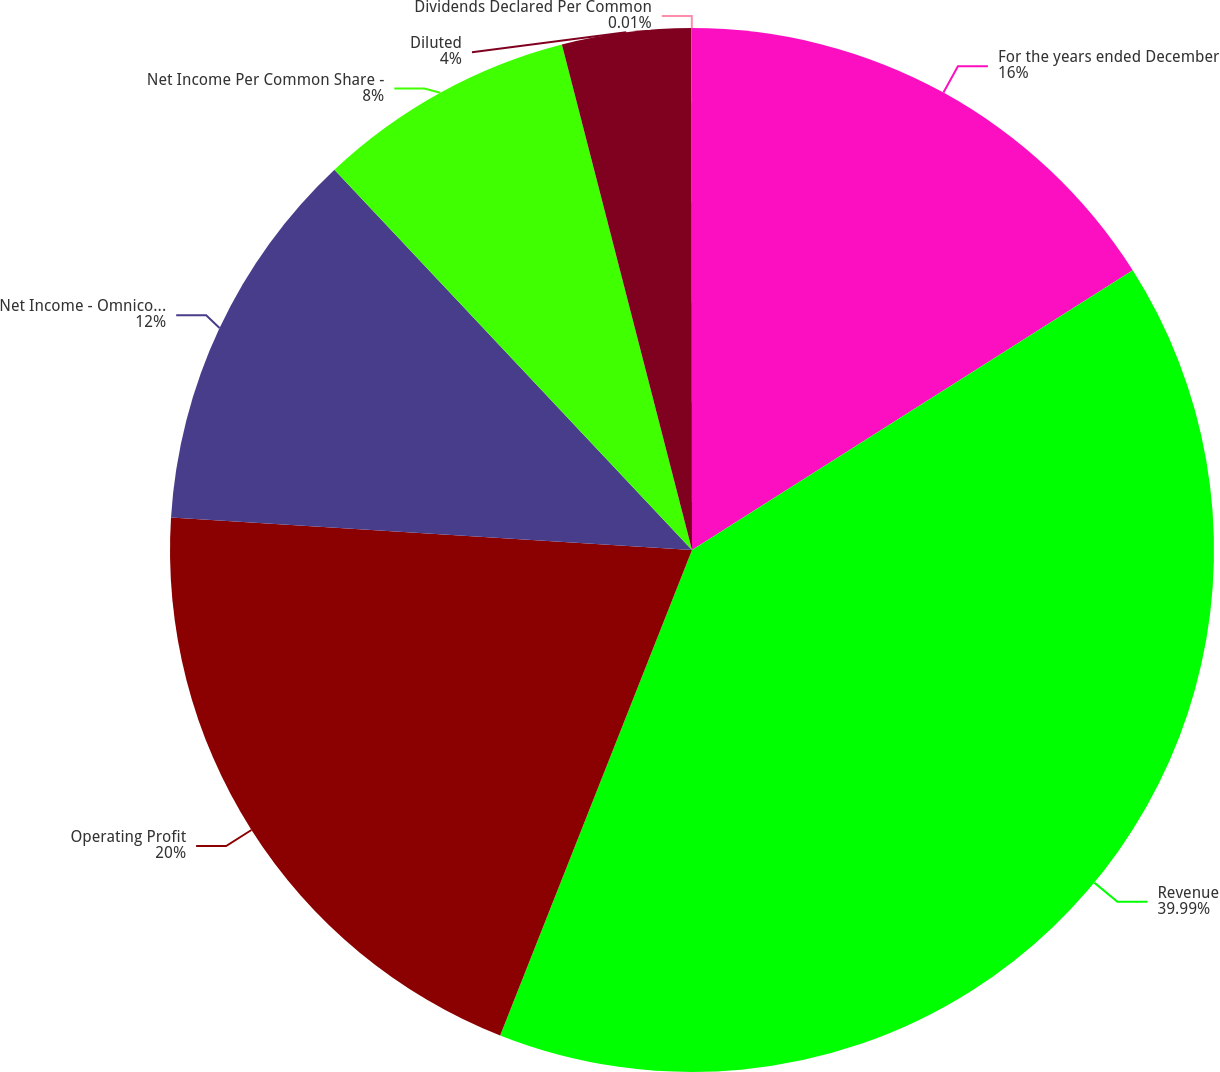Convert chart to OTSL. <chart><loc_0><loc_0><loc_500><loc_500><pie_chart><fcel>For the years ended December<fcel>Revenue<fcel>Operating Profit<fcel>Net Income - Omnicom Group Inc<fcel>Net Income Per Common Share -<fcel>Diluted<fcel>Dividends Declared Per Common<nl><fcel>16.0%<fcel>39.99%<fcel>20.0%<fcel>12.0%<fcel>8.0%<fcel>4.0%<fcel>0.01%<nl></chart> 